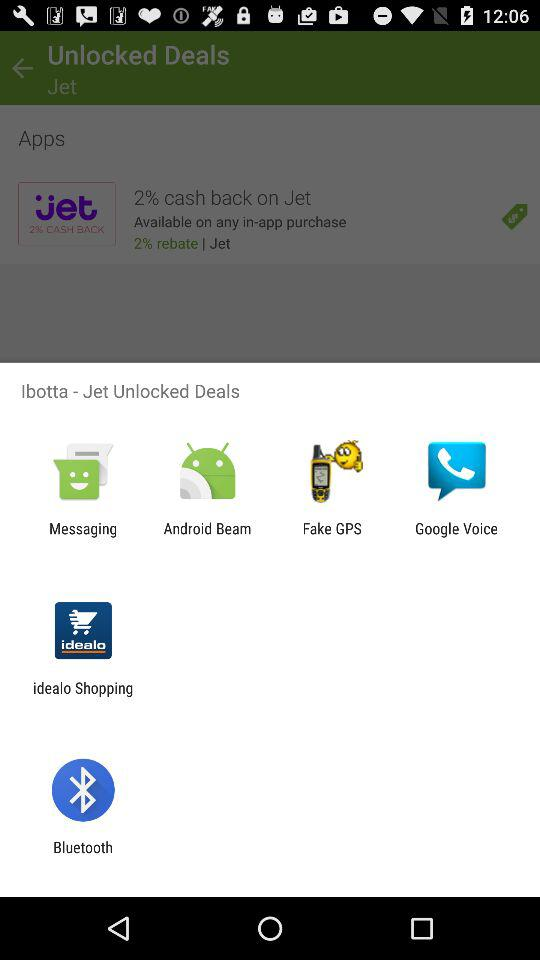How much is the cash back on "Jet"? The cash back on "Jet" is 2%. 